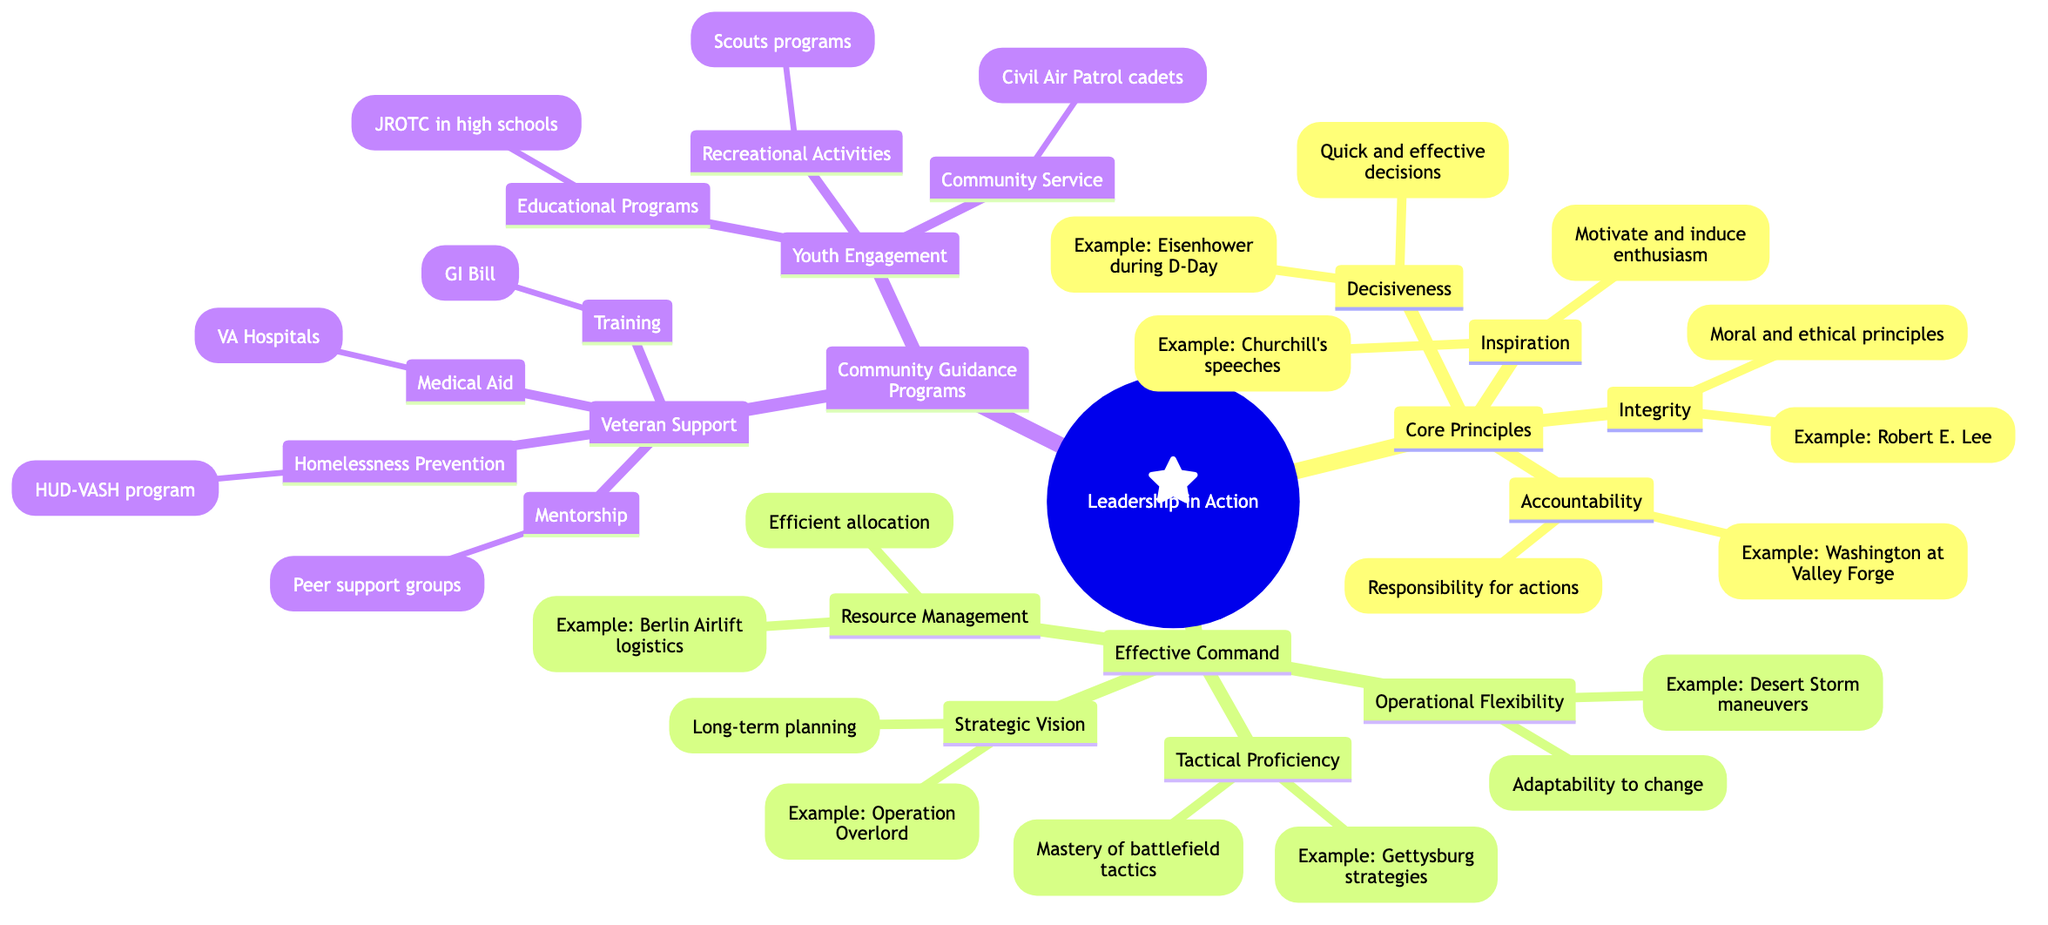What are the core principles of leadership in this diagram? The "Core Principles" node includes "Decisiveness," "Integrity," "Inspiration," and "Accountability." Since these are listed directly under the "Core Principles" node, they contribute to the general understanding of leadership in action.
Answer: Decisiveness, Integrity, Inspiration, Accountability Which historical example is associated with Decisiveness? The relationship between the "Decisiveness" node and its historical example is shown explicitly in the diagram. The example listed is "General Dwight D. Eisenhower during D-Day," which illustrates the principle of decisiveness in leadership.
Answer: General Dwight D. Eisenhower during D-Day What is the definition of Accountability? The definition of "Accountability" is directly provided in the node, stating that it means "Accepting responsibility for actions and decisions." This provides a clear understanding of what accountability entails as a core principle of leadership.
Answer: Accepting responsibility for actions and decisions How many effective command principles are outlined in the diagram? The "Effective Command" node contains four distinct sub-nodes: "Strategic Vision," "Tactical Proficiency," "Resource Management," and "Operational Flexibility." By counting these nodes, one can determine the number of principles related to effective command.
Answer: Four What service is provided under Veteran Support for Medical Aid? The "Medical Aid" category under "Veteran Support" lists "VA Hospitals" as the service provided. This shows a direct connection between the needs of veterans and the service mechanism that addresses those needs.
Answer: VA Hospitals Which example under Community Service shows a sense of civic duty? The "Community Service" sub-node under "Youth Engagement" provides the example of "Civil Air Patrol cadet programs," which illustrates how youth can engage in activities that promote a sense of civic duty. This relationship shows how community service is linked to youth engagement programs.
Answer: Civil Air Patrol cadet programs What is a key benefit of participating in JROTC programs? The "Educational Programs" node notes that JROTC programs in high schools offer "Leadership training and discipline" as key benefits. This highlights the objectives of such educational initiatives within the community engagement spectrum.
Answer: Leadership training and discipline Which historical example is associated with Integrity? The example listed under the "Integrity" node is "General Robert E. Lee despite defeat." This shows a prominent figure in history that embodies the principle of integrity despite the challenges faced.
Answer: General Robert E. Lee despite defeat 